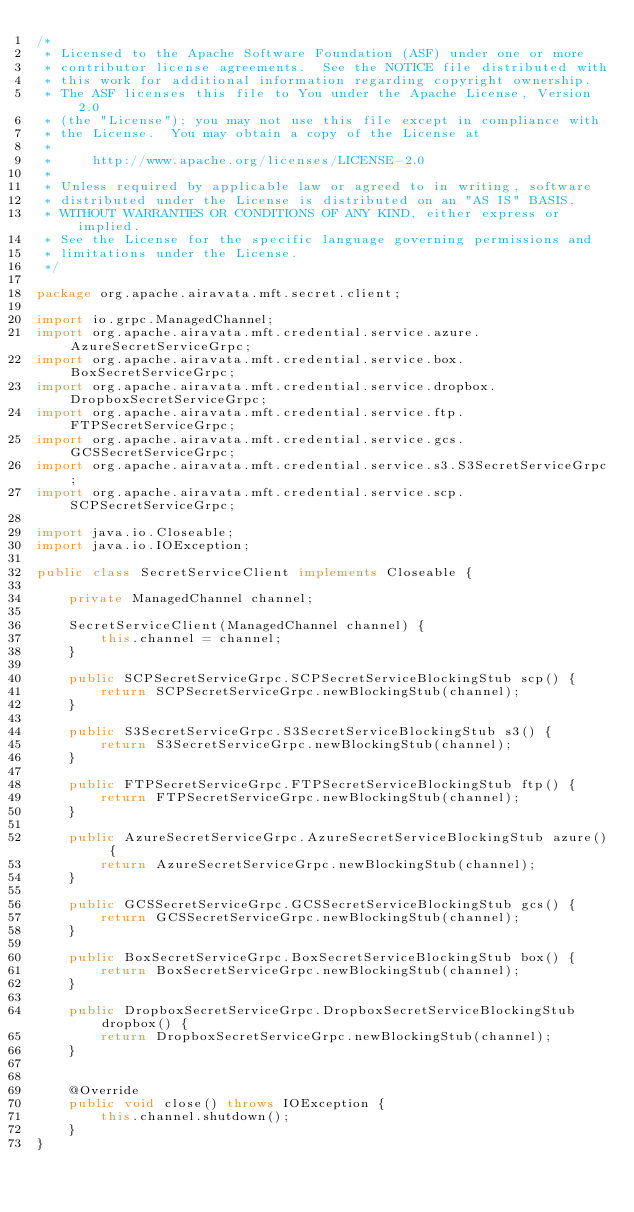<code> <loc_0><loc_0><loc_500><loc_500><_Java_>/*
 * Licensed to the Apache Software Foundation (ASF) under one or more
 * contributor license agreements.  See the NOTICE file distributed with
 * this work for additional information regarding copyright ownership.
 * The ASF licenses this file to You under the Apache License, Version 2.0
 * (the "License"); you may not use this file except in compliance with
 * the License.  You may obtain a copy of the License at
 *
 *     http://www.apache.org/licenses/LICENSE-2.0
 *
 * Unless required by applicable law or agreed to in writing, software
 * distributed under the License is distributed on an "AS IS" BASIS,
 * WITHOUT WARRANTIES OR CONDITIONS OF ANY KIND, either express or implied.
 * See the License for the specific language governing permissions and
 * limitations under the License.
 */

package org.apache.airavata.mft.secret.client;

import io.grpc.ManagedChannel;
import org.apache.airavata.mft.credential.service.azure.AzureSecretServiceGrpc;
import org.apache.airavata.mft.credential.service.box.BoxSecretServiceGrpc;
import org.apache.airavata.mft.credential.service.dropbox.DropboxSecretServiceGrpc;
import org.apache.airavata.mft.credential.service.ftp.FTPSecretServiceGrpc;
import org.apache.airavata.mft.credential.service.gcs.GCSSecretServiceGrpc;
import org.apache.airavata.mft.credential.service.s3.S3SecretServiceGrpc;
import org.apache.airavata.mft.credential.service.scp.SCPSecretServiceGrpc;

import java.io.Closeable;
import java.io.IOException;

public class SecretServiceClient implements Closeable {

    private ManagedChannel channel;

    SecretServiceClient(ManagedChannel channel) {
        this.channel = channel;
    }

    public SCPSecretServiceGrpc.SCPSecretServiceBlockingStub scp() {
        return SCPSecretServiceGrpc.newBlockingStub(channel);
    }

    public S3SecretServiceGrpc.S3SecretServiceBlockingStub s3() {
        return S3SecretServiceGrpc.newBlockingStub(channel);
    }

    public FTPSecretServiceGrpc.FTPSecretServiceBlockingStub ftp() {
        return FTPSecretServiceGrpc.newBlockingStub(channel);
    }

    public AzureSecretServiceGrpc.AzureSecretServiceBlockingStub azure() {
        return AzureSecretServiceGrpc.newBlockingStub(channel);
    }

    public GCSSecretServiceGrpc.GCSSecretServiceBlockingStub gcs() {
        return GCSSecretServiceGrpc.newBlockingStub(channel);
    }

    public BoxSecretServiceGrpc.BoxSecretServiceBlockingStub box() {
        return BoxSecretServiceGrpc.newBlockingStub(channel);
    }

    public DropboxSecretServiceGrpc.DropboxSecretServiceBlockingStub dropbox() {
        return DropboxSecretServiceGrpc.newBlockingStub(channel);
    }


    @Override
    public void close() throws IOException {
        this.channel.shutdown();
    }
}
</code> 